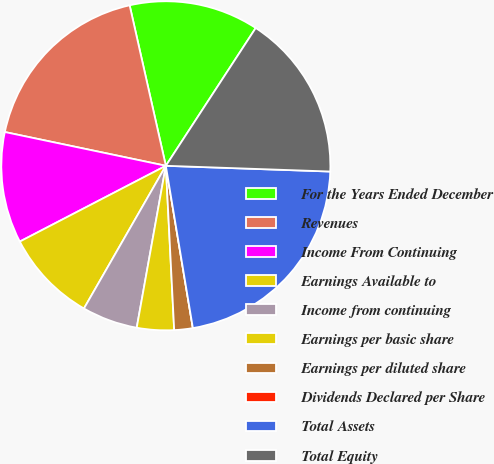Convert chart. <chart><loc_0><loc_0><loc_500><loc_500><pie_chart><fcel>For the Years Ended December<fcel>Revenues<fcel>Income From Continuing<fcel>Earnings Available to<fcel>Income from continuing<fcel>Earnings per basic share<fcel>Earnings per diluted share<fcel>Dividends Declared per Share<fcel>Total Assets<fcel>Total Equity<nl><fcel>12.73%<fcel>18.18%<fcel>10.91%<fcel>9.09%<fcel>5.46%<fcel>3.64%<fcel>1.82%<fcel>0.0%<fcel>21.82%<fcel>16.36%<nl></chart> 